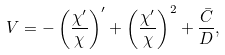Convert formula to latex. <formula><loc_0><loc_0><loc_500><loc_500>V = - \left ( \frac { \chi ^ { \prime } } { \chi } \right ) ^ { \prime } + \left ( \frac { \chi ^ { \prime } } { \chi } \right ) ^ { 2 } + \frac { \bar { C } } { D } ,</formula> 